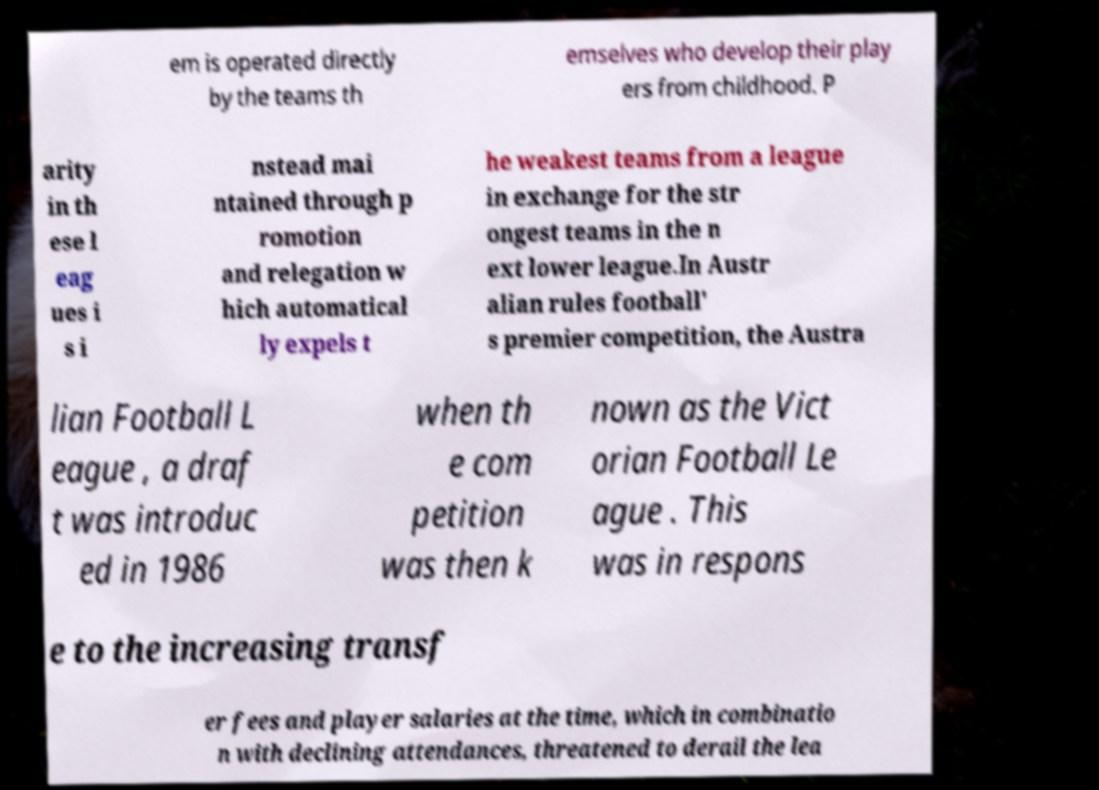Please read and relay the text visible in this image. What does it say? em is operated directly by the teams th emselves who develop their play ers from childhood. P arity in th ese l eag ues i s i nstead mai ntained through p romotion and relegation w hich automatical ly expels t he weakest teams from a league in exchange for the str ongest teams in the n ext lower league.In Austr alian rules football' s premier competition, the Austra lian Football L eague , a draf t was introduc ed in 1986 when th e com petition was then k nown as the Vict orian Football Le ague . This was in respons e to the increasing transf er fees and player salaries at the time, which in combinatio n with declining attendances, threatened to derail the lea 